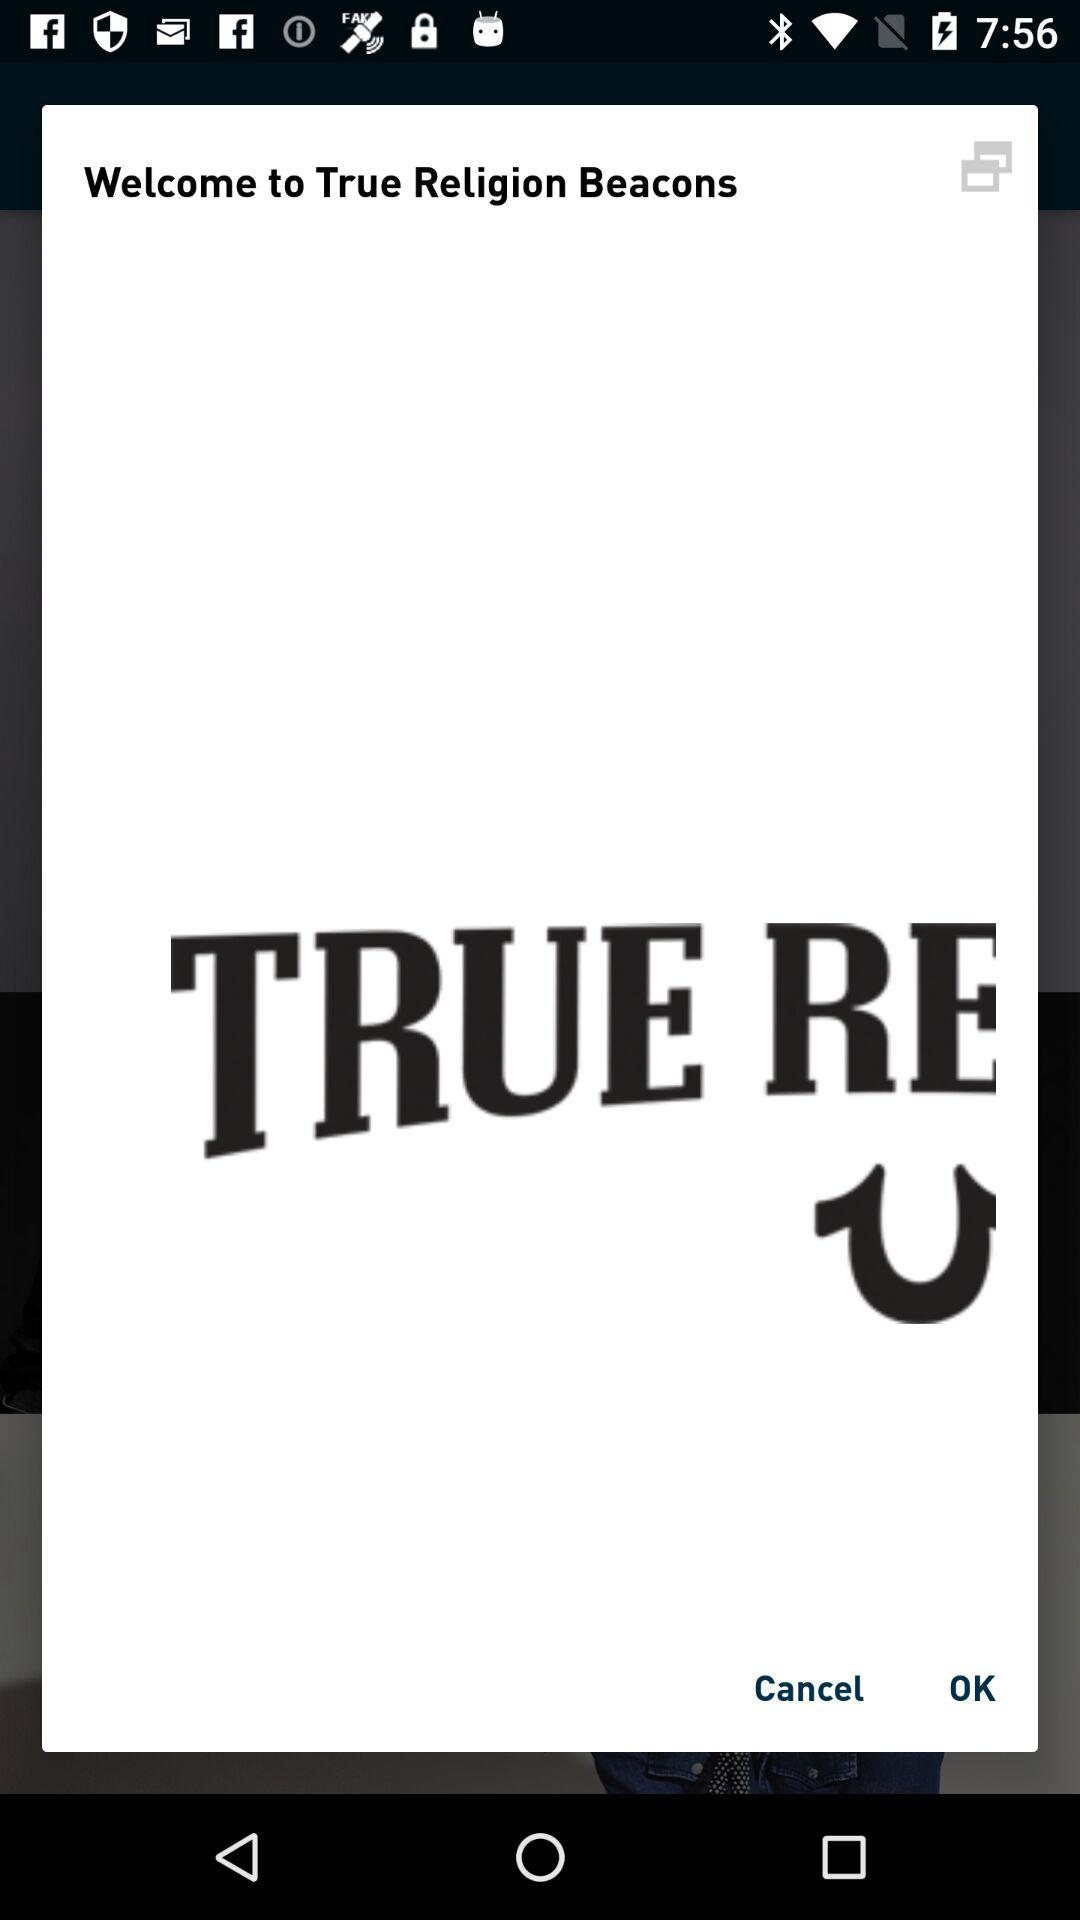What is the name of the application? The name of the application is "True Religion Beacons". 